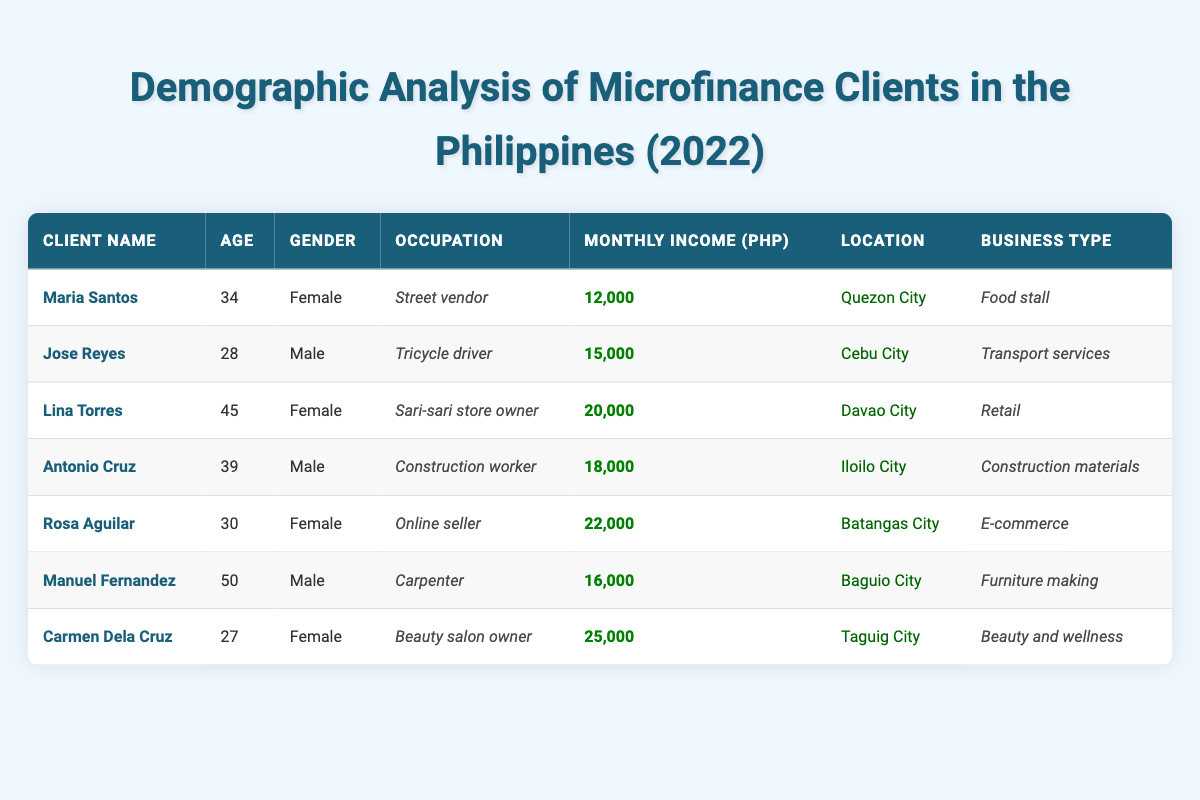What is the occupation of Maria Santos? Referring to the table, Maria Santos is listed under the "Occupation" column, and her occupation is "Street vendor."
Answer: Street vendor How old is Carmen Dela Cruz? In the table, Carmen Dela Cruz's age is mentioned in the "Age" column, which states that she is 27 years old.
Answer: 27 Which client has the highest monthly income? By reviewing the "Monthly Income" column, Rosa Aguilar has the highest income at 22,000 PHP, compared to other clients.
Answer: Rosa Aguilar What is the average age of the microfinance clients? To find the average age, sum all the ages (34 + 28 + 45 + 39 + 30 + 50 + 27 = 253) and divide by the number of clients (7). Therefore, 253/7 = 36.14, which rounds to 36 years old.
Answer: 36 Is Lina Torres a male client? In the table, Lina Torres is listed under the "Gender" column as "Female," which means she is not a male client.
Answer: No What is the total monthly income of all clients combined? The total monthly income can be found by adding all monthly incomes together (12,000 + 15,000 + 20,000 + 18,000 + 22,000 + 16,000 + 25,000 = 128,000 PHP).
Answer: 128,000 PHP Which location has clients that are involved in e-commerce? By inspecting the "Location" and "Business Type" columns, Rosa Aguilar is involved in e-commerce and is located in Batangas City.
Answer: Batangas City Are there more female clients than male clients? Counting and comparing the number of males (Jose Reyes, Antonio Cruz, Manuel Fernandez) which is 3, and females (Maria Santos, Lina Torres, Rosa Aguilar, Carmen Dela Cruz) which totals 4. Therefore, there are more female clients.
Answer: Yes What type of business does Antonio Cruz operate? According to the "Business Type" column, Antonio Cruz operates in "Construction materials."
Answer: Construction materials What is the monthly income difference between the lowest and highest earners? The income difference is calculated by subtracting the lowest income (12,000 PHP for Maria Santos) from the highest (25,000 PHP for Carmen Dela Cruz), which gives us 25,000 - 12,000 = 13,000 PHP.
Answer: 13,000 PHP 